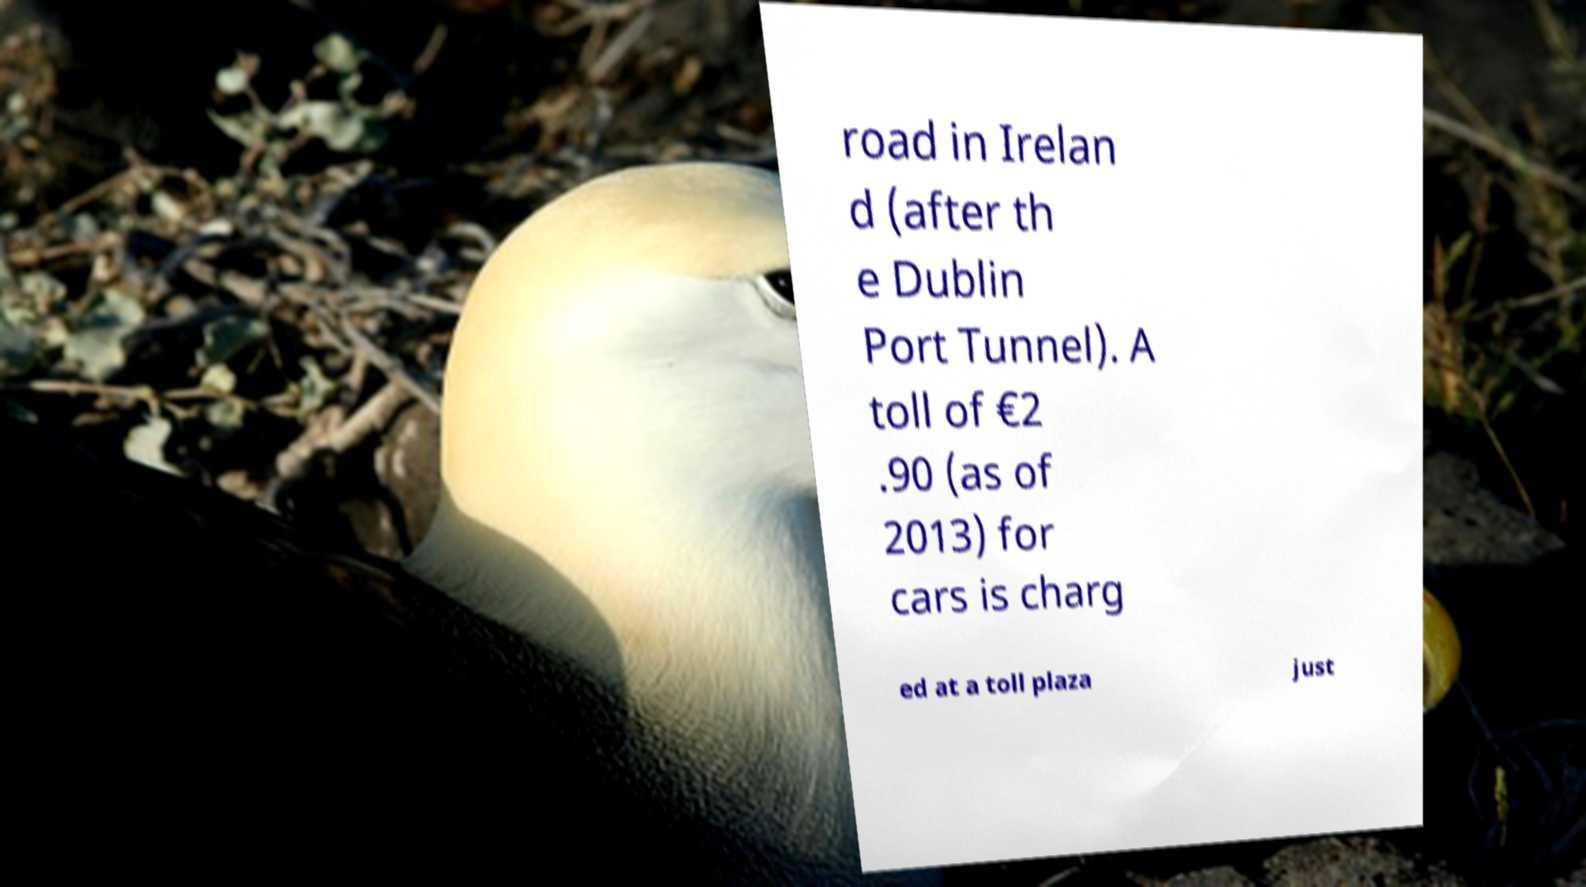For documentation purposes, I need the text within this image transcribed. Could you provide that? road in Irelan d (after th e Dublin Port Tunnel). A toll of €2 .90 (as of 2013) for cars is charg ed at a toll plaza just 